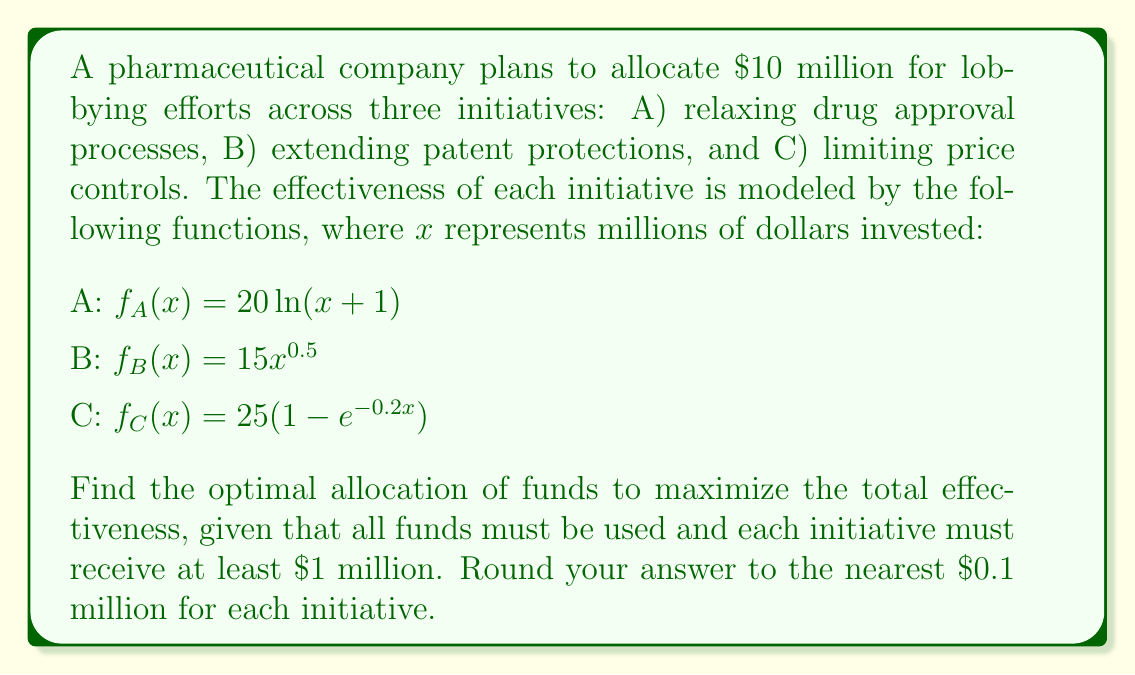Show me your answer to this math problem. To solve this problem, we'll use the method of Lagrange multipliers with constraints:

1) First, we define our objective function:
   $$F(x,y,z) = 20\ln(x+1) + 15y^{0.5} + 25(1-e^{-0.2z})$$

2) We have two constraints:
   $$g(x,y,z) = x + y + z - 10 = 0$$ (total budget constraint)
   $$x \geq 1, y \geq 1, z \geq 1$$ (minimum allocation constraint)

3) We form the Lagrangian:
   $$L(x,y,z,\lambda) = F(x,y,z) - \lambda g(x,y,z)$$

4) We take partial derivatives and set them equal to zero:
   $$\frac{\partial L}{\partial x} = \frac{20}{x+1} - \lambda = 0$$
   $$\frac{\partial L}{\partial y} = \frac{7.5}{y^{0.5}} - \lambda = 0$$
   $$\frac{\partial L}{\partial z} = 5e^{-0.2z} - \lambda = 0$$
   $$\frac{\partial L}{\partial \lambda} = x + y + z - 10 = 0$$

5) From these equations, we can derive:
   $$x = \frac{20}{\lambda} - 1$$
   $$y = (\frac{7.5}{\lambda})^2$$
   $$z = -5\ln(\frac{\lambda}{5})$$

6) Substituting these into the budget constraint:
   $$\frac{20}{\lambda} - 1 + (\frac{7.5}{\lambda})^2 - 5\ln(\frac{\lambda}{5}) = 10$$

7) This equation can be solved numerically to find $\lambda \approx 3.86$

8) Substituting this value back into our expressions for x, y, and z:
   $$x \approx 4.2$$
   $$y \approx 3.8$$
   $$z \approx 2.0$$

9) These values satisfy the minimum allocation constraint, so they represent our optimal solution.
Answer: The optimal allocation rounded to the nearest $0.1 million is:
Initiative A: $4.2 million
Initiative B: $3.8 million
Initiative C: $2.0 million 